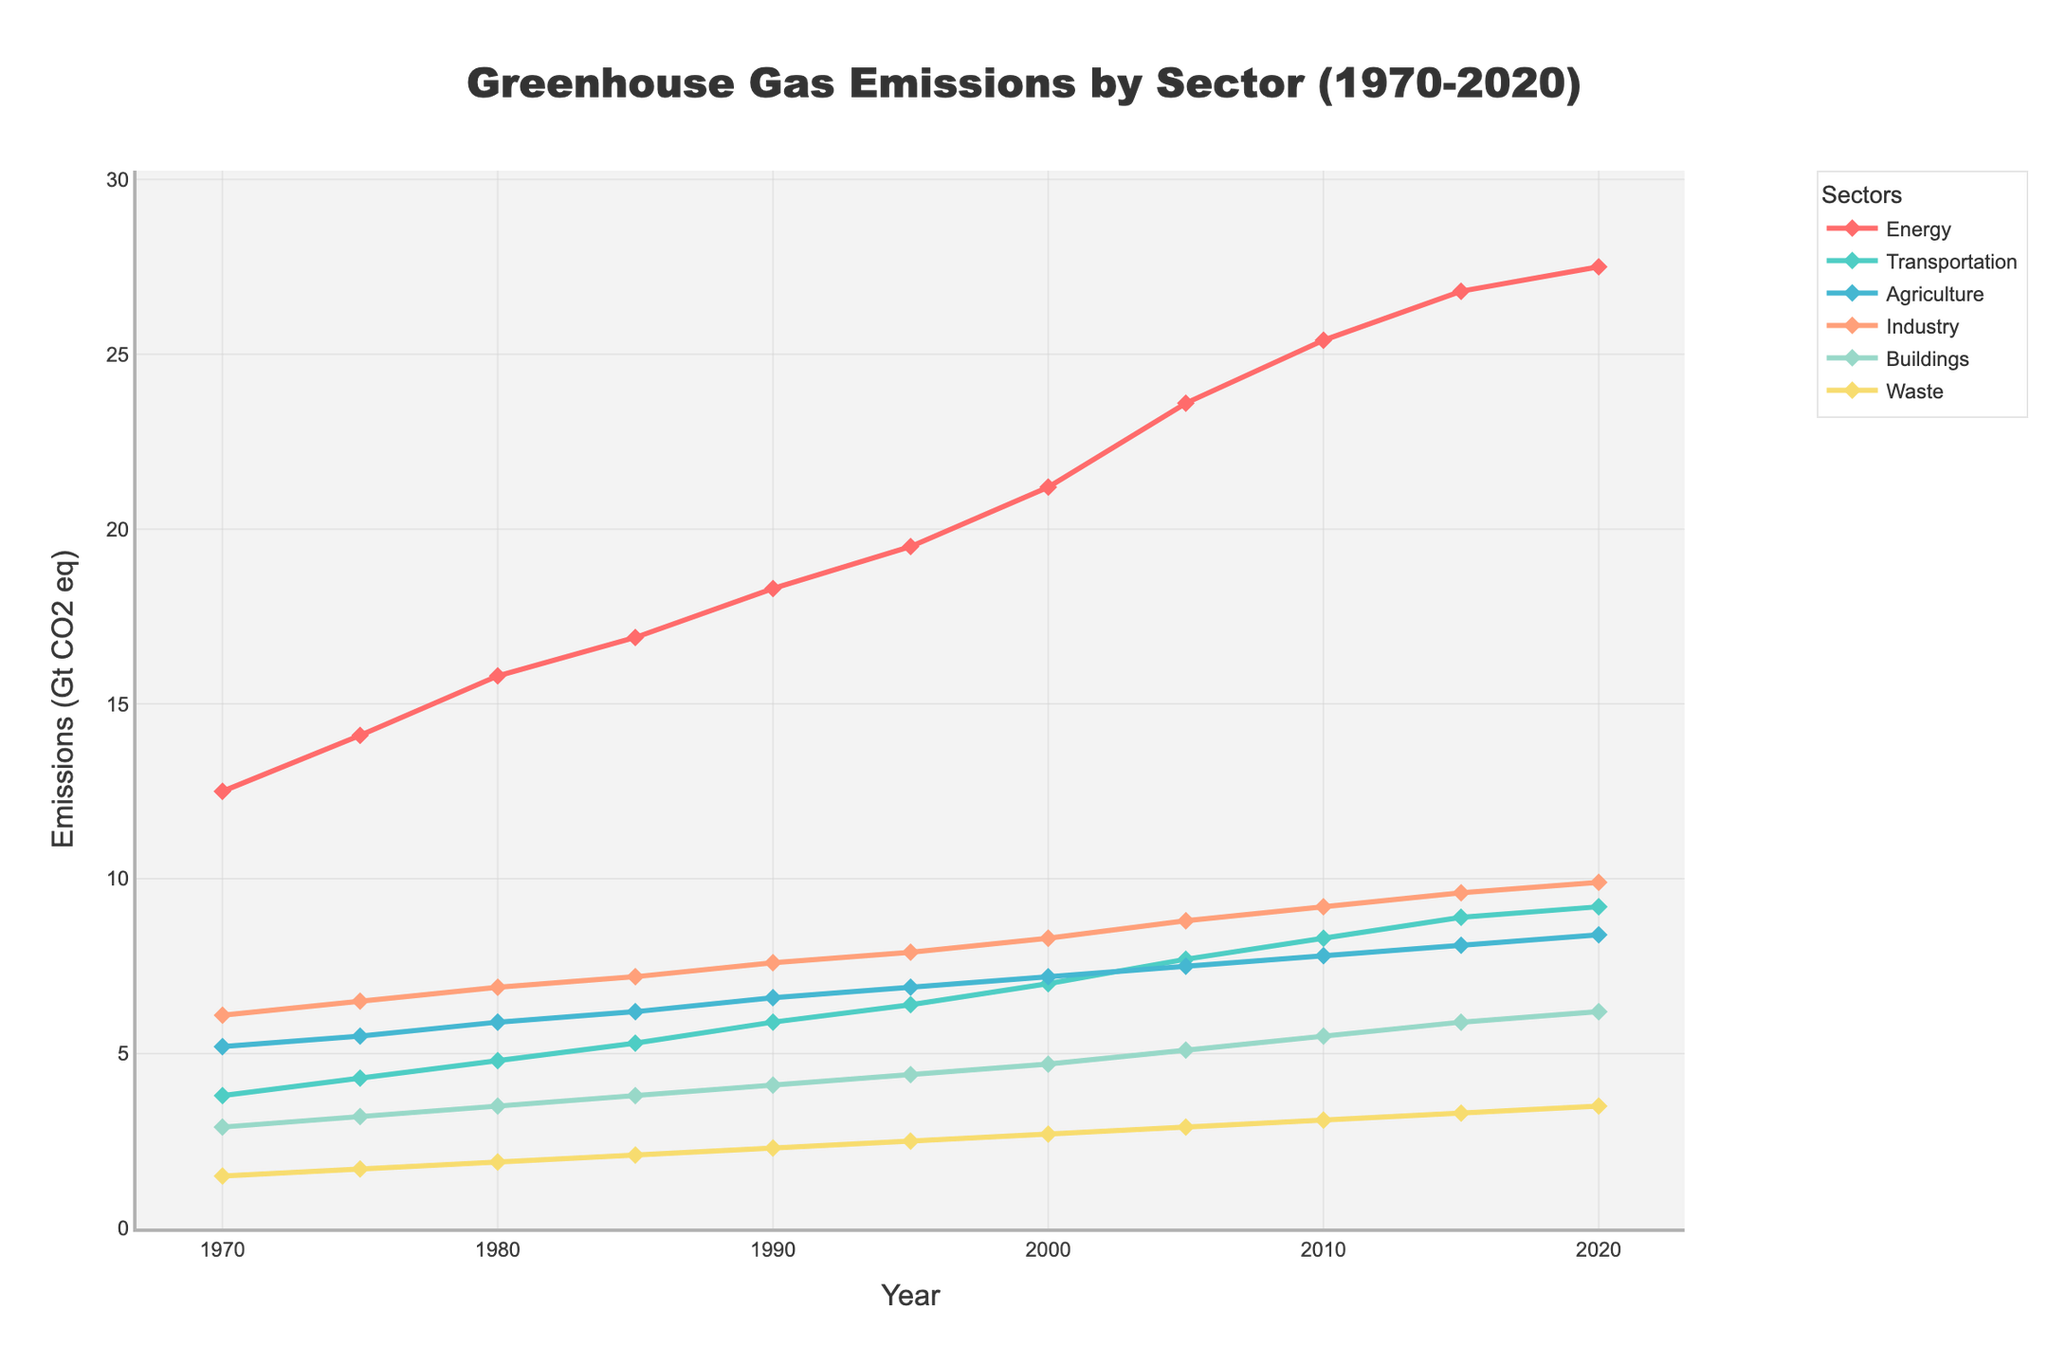What sector had the highest greenhouse gas emissions in 1970? By observing the height and values at the year 1970 for each sector, we see that Energy has the highest value at 12.5 Gt CO2 eq
Answer: Energy How much did emissions from the Transportation sector increase from 1970 to 2020? In 1970, Transportation had 3.8 Gt CO2 eq emissions, and in 2020, it had 9.2 Gt CO2 eq. The increase is 9.2 - 3.8 = 5.4 Gt CO2 eq
Answer: 5.4 Gt CO2 eq Which sector experienced the smallest increase in emissions from 1970 to 2020? By observing the differences in emissions from 1970 and 2020 for each sector and comparing them, Waste increased from 1.5 to 3.5 Gt CO2 eq, which is the smallest increase of 2 Gt CO2 eq
Answer: Waste In 2020, which sector had emissions closest to 10 Gt CO2 eq? By observing the values for 2020, the Industry sector has emissions at 9.9 Gt CO2 eq, which is the closest to 10 Gt CO2 eq
Answer: Industry Between which consecutive years was the largest increase in emissions for the Agriculture sector observed? By examining the differences between consecutive years for Agriculture, the largest increase is between 1985 and 1990, increasing from 6.2 to 6.6 Gt CO2 eq
Answer: 1985 to 1990 How do emissions from the Buildings sector in 1990 compare to those in 2020? In 1990, Buildings emitted 4.1 Gt CO2 eq, while in 2020, the emissions were 6.2 Gt CO2 eq. 6.2 is greater than 4.1
Answer: 6.2 > 4.1 What is the average emission for the Industry sector over the 50 years? Sum all Industry emissions from 1970 to 2020 and divide by the number of years: (6.1 + 6.5 + 6.9 + 7.2 + 7.6 + 7.9 + 8.3 + 8.8 + 9.2 + 9.6 + 9.9) / 11 = 8.09 Gt CO2 eq
Answer: 8.09 Gt CO2 eq Which sector showed the least change in emissions between 2010 and 2015? By comparing the differences between 2010 and 2015 for each sector, Transportation increased from 8.3 to 8.9 Gt CO2 eq, which is the least change of 0.6 Gt CO2 eq
Answer: Transportation If we sum the emissions from Buildings and Waste in 2000, what do we get? In 2000, Buildings had 4.7 Gt CO2 eq and Waste had 2.7 Gt CO2 eq. Summing them, we get 4.7 + 2.7 = 7.4 Gt CO2 eq
Answer: 7.4 Gt CO2 eq Which sector showed a steady increase in emissions over the entire period from 1970 to 2020? By visually inspecting the trends for each sector, the Energy sector showed a continuous and steady increase in emissions over the entire period
Answer: Energy 